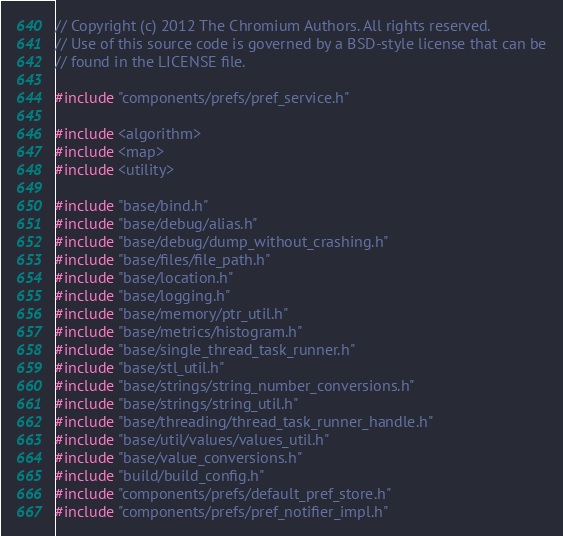Convert code to text. <code><loc_0><loc_0><loc_500><loc_500><_C++_>// Copyright (c) 2012 The Chromium Authors. All rights reserved.
// Use of this source code is governed by a BSD-style license that can be
// found in the LICENSE file.

#include "components/prefs/pref_service.h"

#include <algorithm>
#include <map>
#include <utility>

#include "base/bind.h"
#include "base/debug/alias.h"
#include "base/debug/dump_without_crashing.h"
#include "base/files/file_path.h"
#include "base/location.h"
#include "base/logging.h"
#include "base/memory/ptr_util.h"
#include "base/metrics/histogram.h"
#include "base/single_thread_task_runner.h"
#include "base/stl_util.h"
#include "base/strings/string_number_conversions.h"
#include "base/strings/string_util.h"
#include "base/threading/thread_task_runner_handle.h"
#include "base/util/values/values_util.h"
#include "base/value_conversions.h"
#include "build/build_config.h"
#include "components/prefs/default_pref_store.h"
#include "components/prefs/pref_notifier_impl.h"</code> 